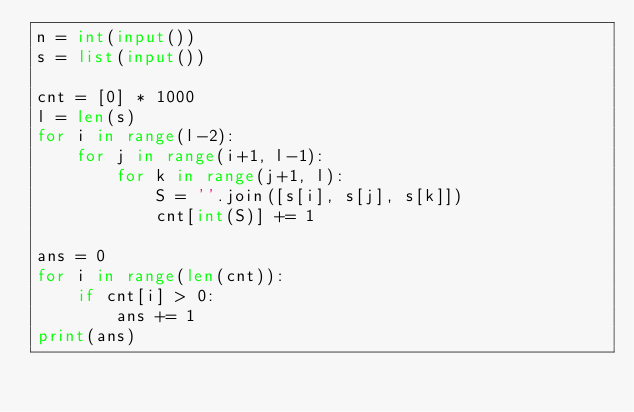<code> <loc_0><loc_0><loc_500><loc_500><_Python_>n = int(input())
s = list(input())

cnt = [0] * 1000
l = len(s)
for i in range(l-2):
    for j in range(i+1, l-1):
        for k in range(j+1, l):
            S = ''.join([s[i], s[j], s[k]])
            cnt[int(S)] += 1

ans = 0
for i in range(len(cnt)):
    if cnt[i] > 0:
        ans += 1
print(ans)</code> 